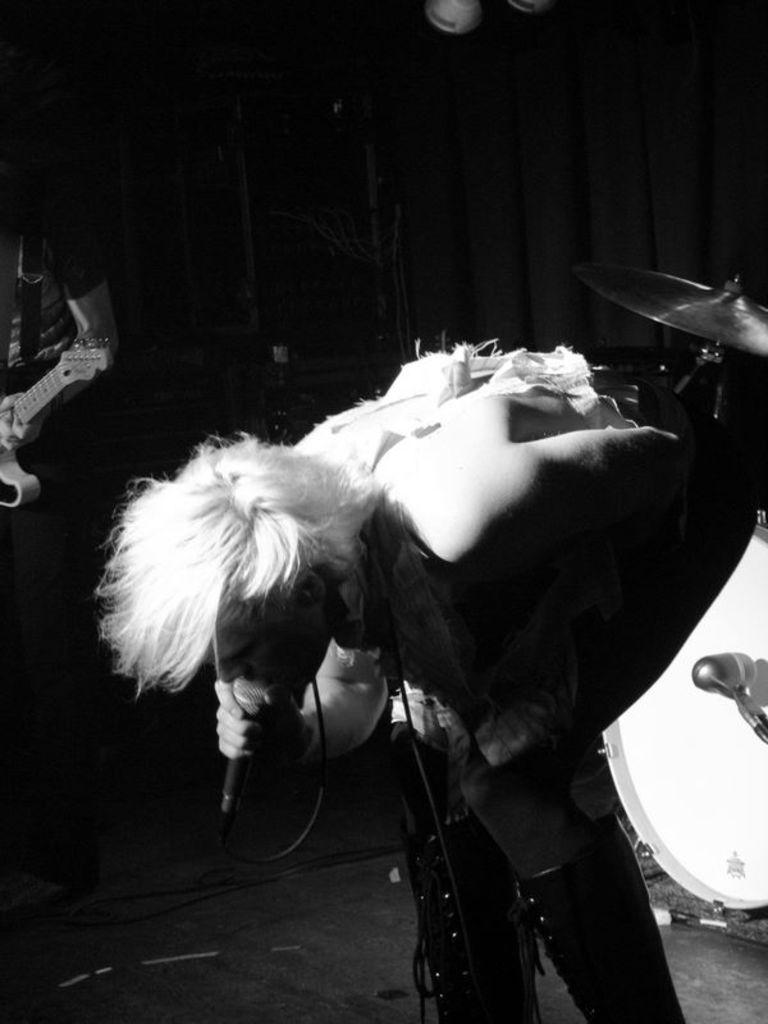What is the person in the image holding? The person in the image is holding a mic. What musical instrument can be seen in the image? There are drums and a guitar in the image. What else is present in the image besides the people and instruments? There are wires and some unspecified objects in the image. How would you describe the lighting in the image? The background of the image is dark. How many deer are visible in the image? There are no deer present in the image. What type of sign is being held by the person in the image? The person in the image is not holding a sign; they are holding a mic. 